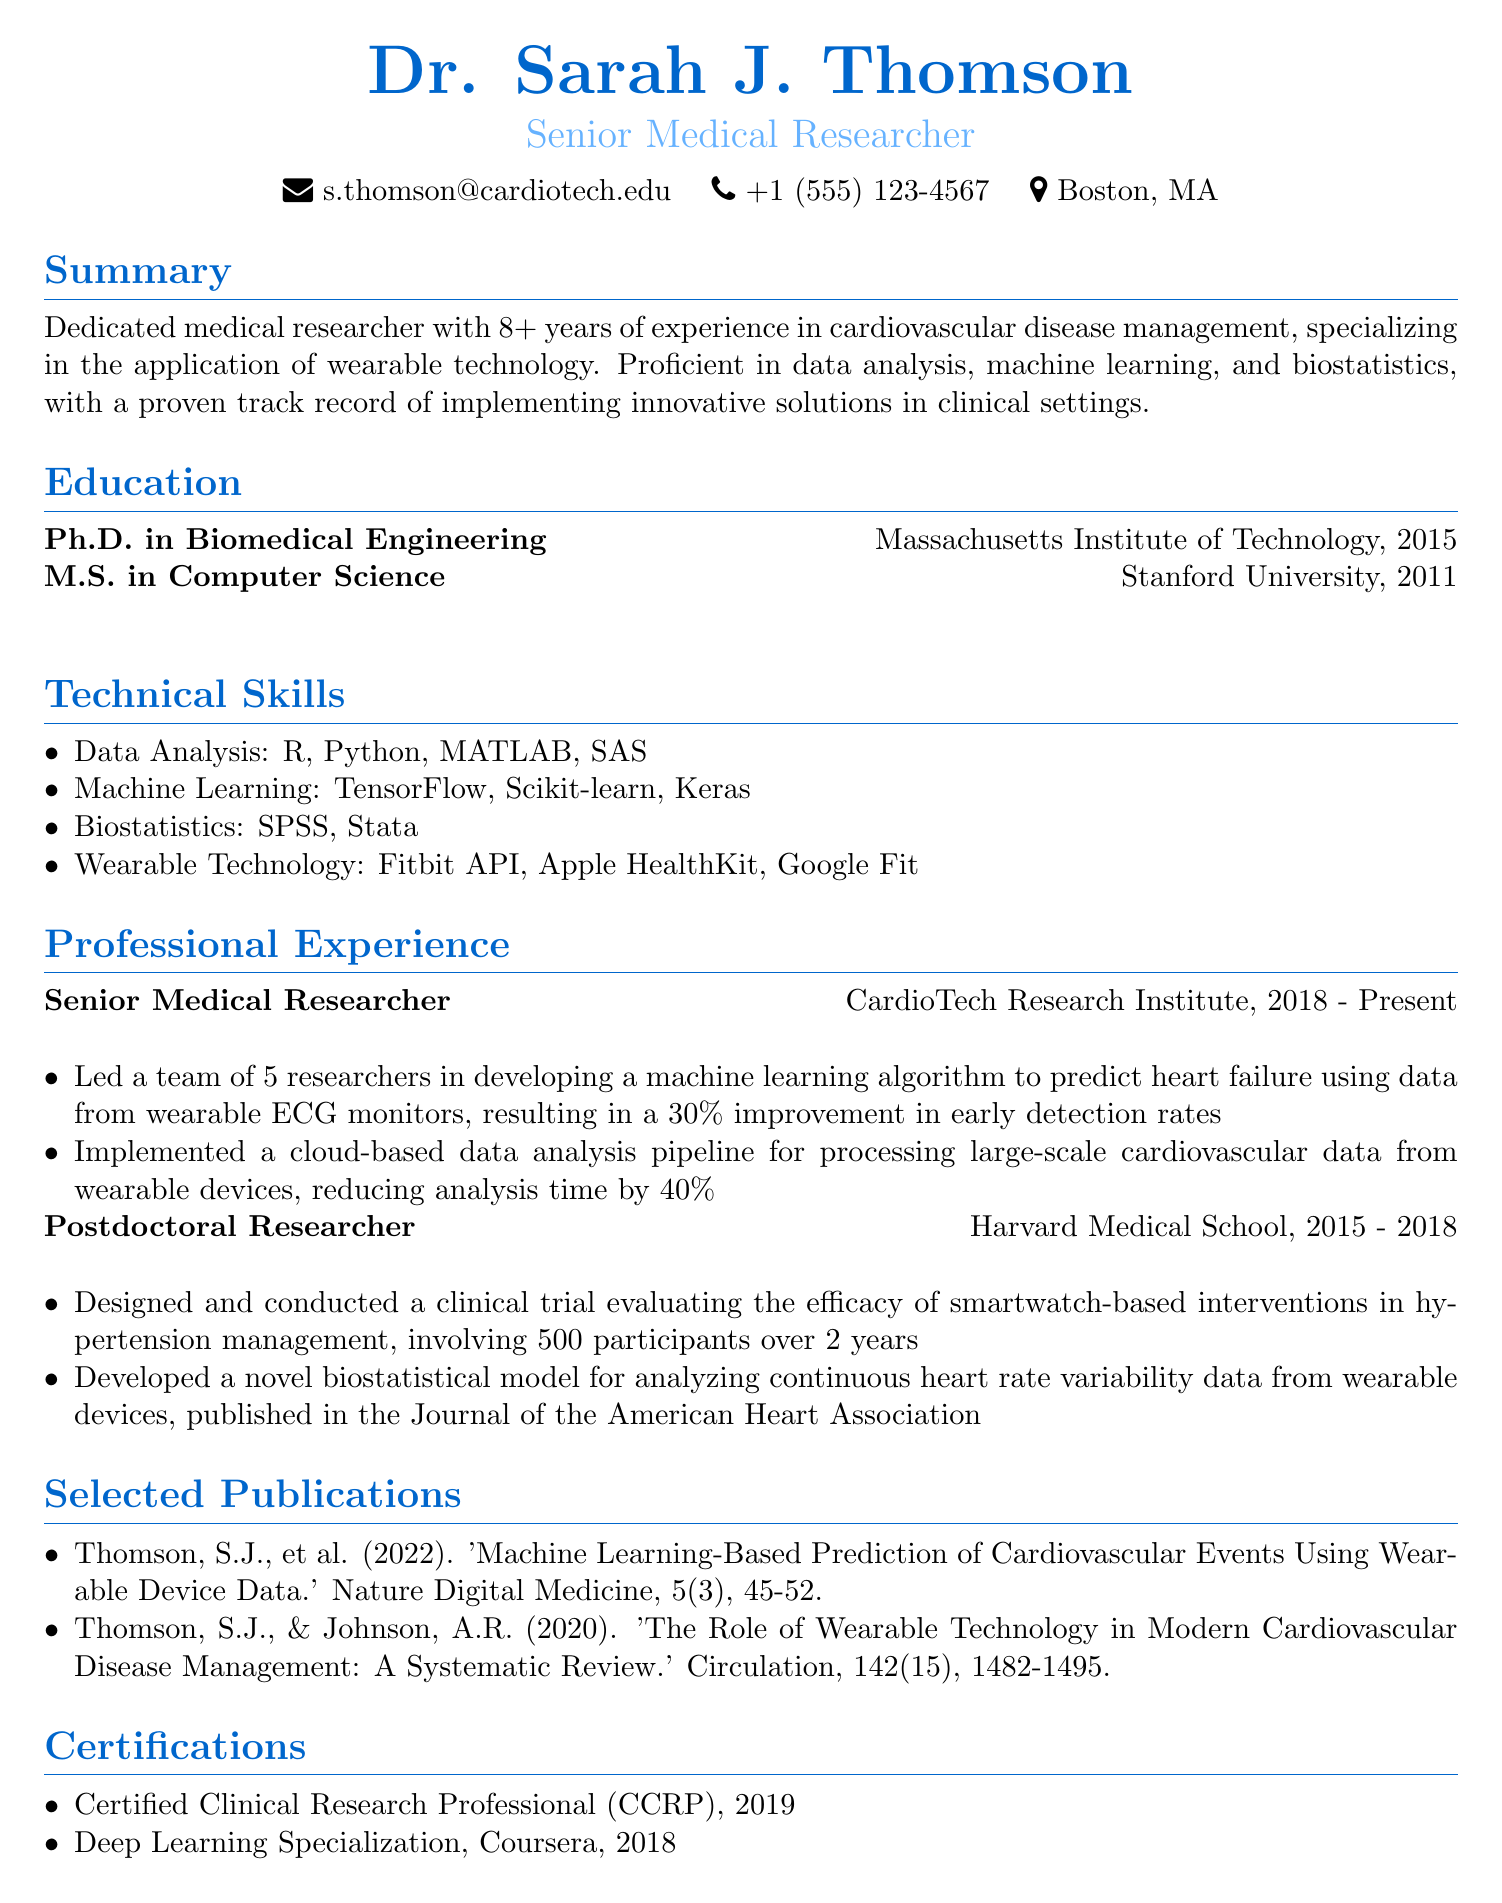what is Dr. Sarah J. Thomson's job title? The job title is explicitly mentioned in the document as "Senior Medical Researcher."
Answer: Senior Medical Researcher what institution did Dr. Thomson receive her Ph.D. from? The document lists "Massachusetts Institute of Technology" as the institution for her Ph.D. degree.
Answer: Massachusetts Institute of Technology how many years of experience does Dr. Thomson have in cardiovascular disease management? The summary states that Dr. Thomson has "8+ years" of experience in this field.
Answer: 8+ years what machine learning framework did Dr. Thomson use to develop a predictive algorithm for heart failure? The document specifies the use of a "machine learning algorithm," and "TensorFlow" is one of the frameworks within her technical skills related to this research.
Answer: TensorFlow which wearable technology was specifically noted in Dr. Thomson's technical skills? The document lists multiple wearable technologies, but "Fitbit API" is explicitly mentioned.
Answer: Fitbit API how many participants were involved in the clinical trial designed by Dr. Thomson at Harvard Medical School? The document provides the number of participants in that trial as "500."
Answer: 500 what significant improvement was achieved in early detection rates for heart failure through Dr. Thomson's research? The document highlights a "30% improvement in early detection rates" as a result of the research.
Answer: 30% in what year did Dr. Thomson complete her Master's degree? The education section states that she completed her M.S. in "2011."
Answer: 2011 which journal published Dr. Thomson's biostatistical model on heart rate variability? The document specifies the "Journal of the American Heart Association" as the publication for her research.
Answer: Journal of the American Heart Association 